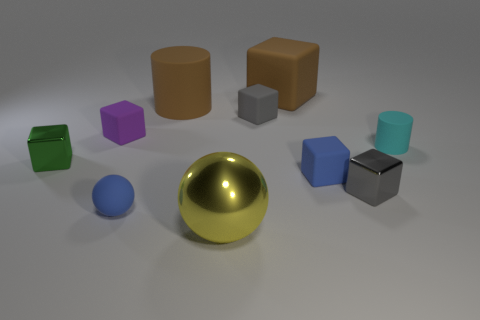There is a gray matte cube; does it have the same size as the sphere that is behind the yellow sphere?
Keep it short and to the point. Yes. How many other things are there of the same size as the cyan cylinder?
Offer a very short reply. 6. How many other things are there of the same color as the big rubber cylinder?
Ensure brevity in your answer.  1. What number of other objects are there of the same shape as the cyan thing?
Your response must be concise. 1. Is the brown cube the same size as the cyan matte cylinder?
Ensure brevity in your answer.  No. Are there any small green cubes?
Provide a succinct answer. Yes. Is there another sphere made of the same material as the large yellow sphere?
Your answer should be compact. No. There is a green block that is the same size as the cyan rubber object; what is its material?
Give a very brief answer. Metal. What number of other small gray objects are the same shape as the small gray metal object?
Offer a terse response. 1. There is a blue block that is made of the same material as the brown cube; what size is it?
Your answer should be compact. Small. 